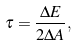<formula> <loc_0><loc_0><loc_500><loc_500>\tau = \frac { \Delta E } { 2 \Delta A } ,</formula> 